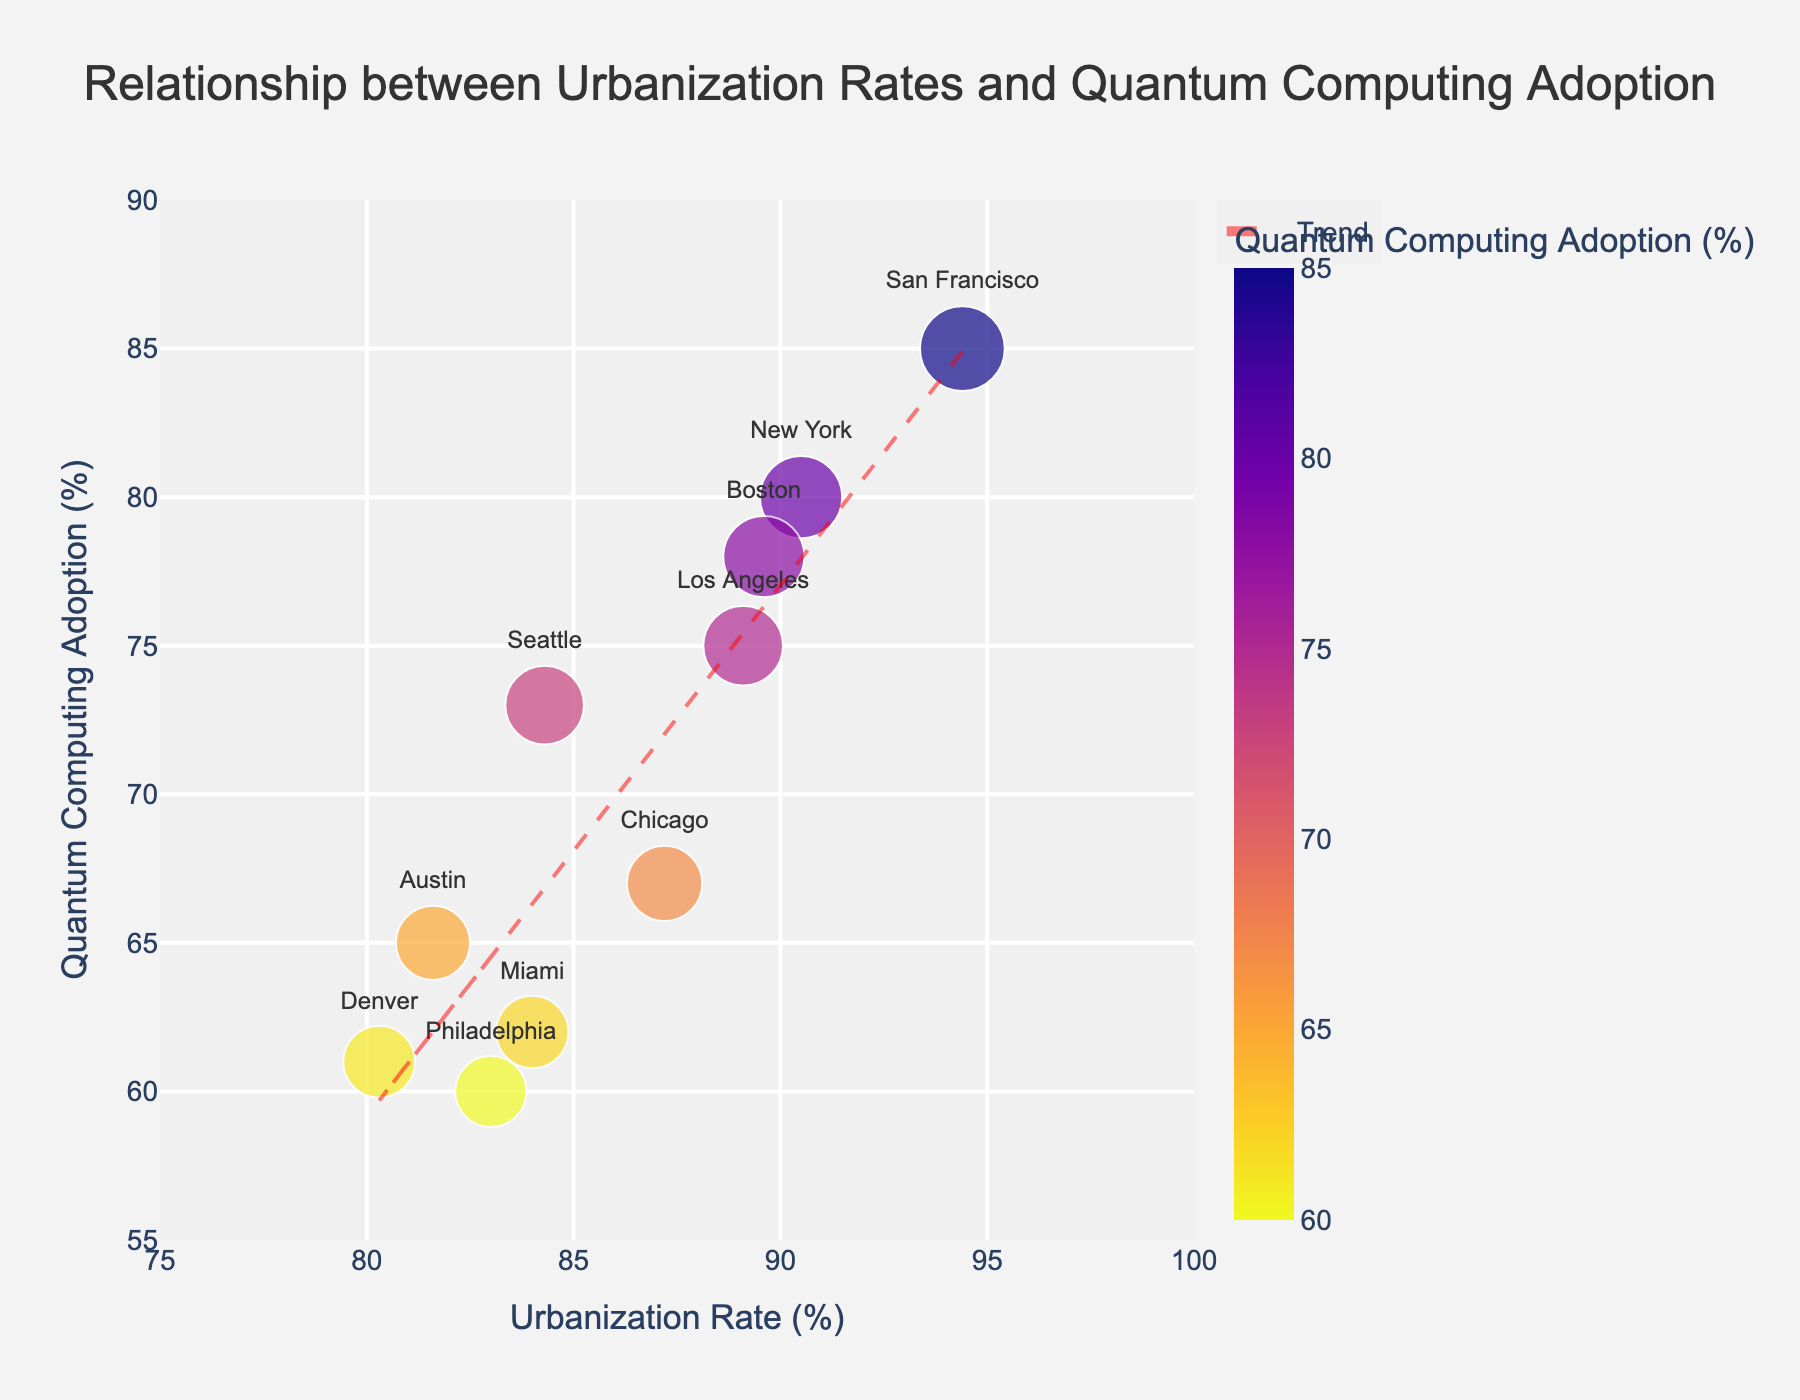What is the title of the scatter plot? The title is usually displayed at the top of the plot. In this case, it reads "Relationship between Urbanization Rates and Quantum Computing Adoption".
Answer: Relationship between Urbanization Rates and Quantum Computing Adoption What does the x-axis represent? The x-axis label provides information about what the axis represents. Here, it indicates "Urbanization Rate (%)", which means the percentage of urbanization in each city.
Answer: Urbanization Rate (%) What does the y-axis represent? Similar to the x-axis, the y-axis label indicates what it represents. Here, it reads "Quantum Computing Adoption (%)", which refers to the percentage of adoption of quantum computing applications in each city.
Answer: Quantum Computing Adoption (%) Which city has the highest urbanization rate? By looking at the data points along the x-axis, locate the one that is furthest to the right. San Francisco is positioned at 94.4%, which is the highest.
Answer: San Francisco Which city has the lowest quantum computing adoption rate? Identify the data point positioned lowest on the y-axis. Philadelphia, with a rate of 60%, has the lowest adoption.
Answer: Philadelphia What is the general trend indicated by the trend line? The trend line gives a visual cue about the overall relationship between urbanization rates and quantum computing adoption. Since the trend line slopes upwards, it indicates a positive correlation.
Answer: Positive correlation What is the urbanization rate and quantum computing adoption rate of New York? Locate the label "New York" on the plot, and note its coordinates. The x-coordinate for urbanization rate is 90.5%, and the y-coordinate for quantum computing adoption rate is 80%.
Answer: Urbanization Rate: 90.5%, Quantum Computing Adoption: 80% By how much is Boston's quantum computing adoption rate higher than Philadelphia's? Find Boston and Philadelphia on the y-axis. Boston's quantum computing adoption is 78%, and Philadelphia's is 60%. Calculation: 78% - 60% = 18%.
Answer: 18% What is the average urbanization rate of all the cities? Sum the urbanization rates: (94.4 + 90.5 + 87.2 + 89.1 + 84.3 + 81.6 + 89.6 + 84 + 80.3 + 83) = 864. Divide by the number of cities (10): 864/10 = 86.4%.
Answer: 86.4% How many cities have a quantum computing adoption rate greater than 70%? Count the data points whose y-coordinate is greater than 70%. Here, San Francisco, New York, Los Angeles, Seattle, and Boston satisfy this condition, giving a total of 5 cities.
Answer: 5 